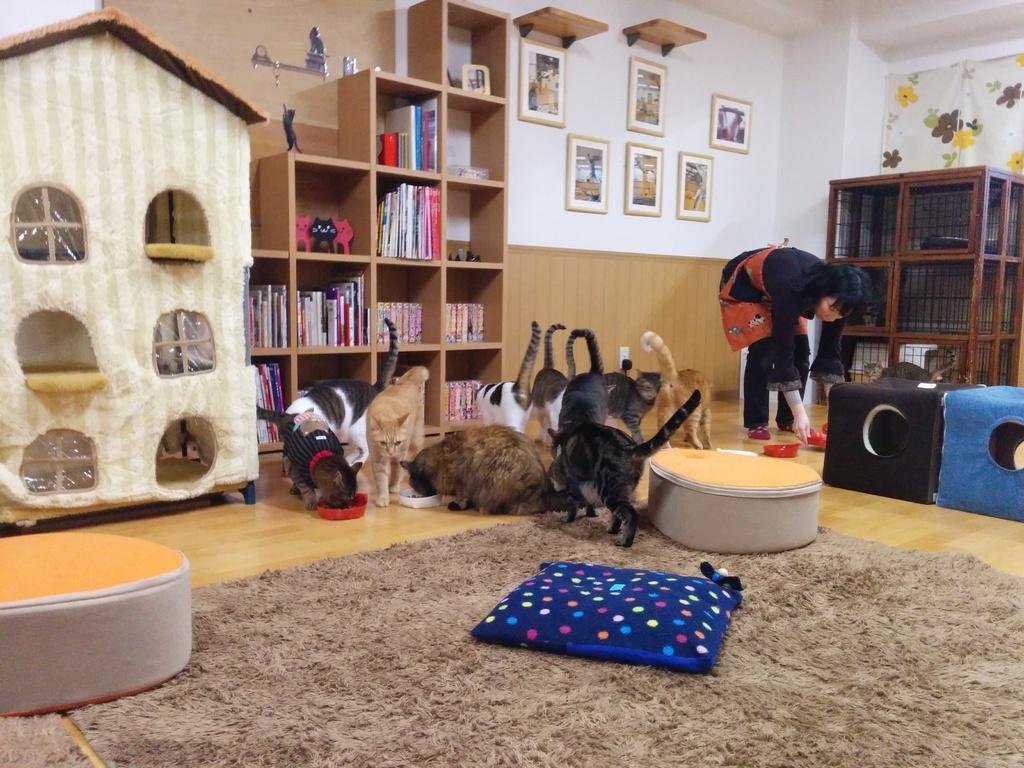In one or two sentences, can you explain what this image depicts? In this image, I can see the cats and a person standing. I can see the pet beds, a cushion and carpet on the floor. These are the books and few other objects in the rack. I can see the photo frames attached to the wall. On the right side of the image, these are the cages. On the left side of the image, I can see a pet house. 